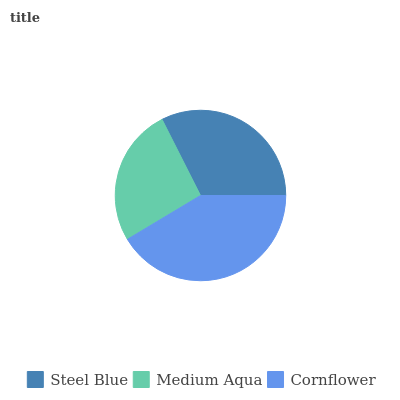Is Medium Aqua the minimum?
Answer yes or no. Yes. Is Cornflower the maximum?
Answer yes or no. Yes. Is Cornflower the minimum?
Answer yes or no. No. Is Medium Aqua the maximum?
Answer yes or no. No. Is Cornflower greater than Medium Aqua?
Answer yes or no. Yes. Is Medium Aqua less than Cornflower?
Answer yes or no. Yes. Is Medium Aqua greater than Cornflower?
Answer yes or no. No. Is Cornflower less than Medium Aqua?
Answer yes or no. No. Is Steel Blue the high median?
Answer yes or no. Yes. Is Steel Blue the low median?
Answer yes or no. Yes. Is Cornflower the high median?
Answer yes or no. No. Is Cornflower the low median?
Answer yes or no. No. 